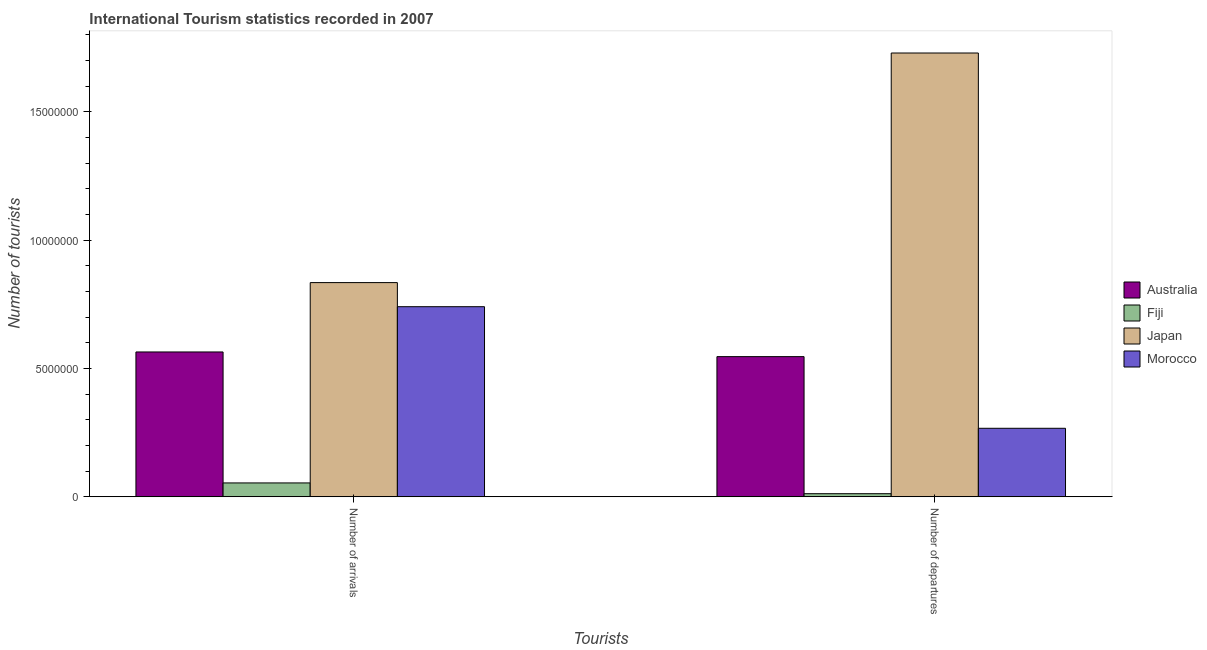How many different coloured bars are there?
Ensure brevity in your answer.  4. How many groups of bars are there?
Make the answer very short. 2. Are the number of bars on each tick of the X-axis equal?
Your response must be concise. Yes. What is the label of the 1st group of bars from the left?
Provide a short and direct response. Number of arrivals. What is the number of tourist departures in Australia?
Your answer should be compact. 5.46e+06. Across all countries, what is the maximum number of tourist arrivals?
Your response must be concise. 8.35e+06. Across all countries, what is the minimum number of tourist departures?
Provide a short and direct response. 1.20e+05. In which country was the number of tourist departures minimum?
Offer a terse response. Fiji. What is the total number of tourist departures in the graph?
Offer a terse response. 2.55e+07. What is the difference between the number of tourist arrivals in Australia and that in Japan?
Keep it short and to the point. -2.70e+06. What is the difference between the number of tourist departures in Japan and the number of tourist arrivals in Morocco?
Keep it short and to the point. 9.89e+06. What is the average number of tourist arrivals per country?
Offer a very short reply. 5.48e+06. What is the difference between the number of tourist departures and number of tourist arrivals in Australia?
Provide a succinct answer. -1.82e+05. In how many countries, is the number of tourist departures greater than 16000000 ?
Provide a succinct answer. 1. What is the ratio of the number of tourist arrivals in Morocco to that in Fiji?
Keep it short and to the point. 13.72. In how many countries, is the number of tourist departures greater than the average number of tourist departures taken over all countries?
Make the answer very short. 1. What does the 3rd bar from the left in Number of departures represents?
Provide a succinct answer. Japan. How many bars are there?
Offer a terse response. 8. How many countries are there in the graph?
Make the answer very short. 4. Are the values on the major ticks of Y-axis written in scientific E-notation?
Your answer should be very brief. No. Does the graph contain grids?
Provide a succinct answer. No. Where does the legend appear in the graph?
Ensure brevity in your answer.  Center right. How many legend labels are there?
Your answer should be very brief. 4. What is the title of the graph?
Offer a terse response. International Tourism statistics recorded in 2007. Does "Palau" appear as one of the legend labels in the graph?
Provide a succinct answer. No. What is the label or title of the X-axis?
Give a very brief answer. Tourists. What is the label or title of the Y-axis?
Provide a succinct answer. Number of tourists. What is the Number of tourists of Australia in Number of arrivals?
Your answer should be very brief. 5.64e+06. What is the Number of tourists of Fiji in Number of arrivals?
Offer a very short reply. 5.40e+05. What is the Number of tourists of Japan in Number of arrivals?
Provide a succinct answer. 8.35e+06. What is the Number of tourists of Morocco in Number of arrivals?
Your answer should be very brief. 7.41e+06. What is the Number of tourists of Australia in Number of departures?
Provide a succinct answer. 5.46e+06. What is the Number of tourists of Fiji in Number of departures?
Keep it short and to the point. 1.20e+05. What is the Number of tourists of Japan in Number of departures?
Your response must be concise. 1.73e+07. What is the Number of tourists in Morocco in Number of departures?
Provide a short and direct response. 2.67e+06. Across all Tourists, what is the maximum Number of tourists of Australia?
Give a very brief answer. 5.64e+06. Across all Tourists, what is the maximum Number of tourists in Fiji?
Your response must be concise. 5.40e+05. Across all Tourists, what is the maximum Number of tourists of Japan?
Give a very brief answer. 1.73e+07. Across all Tourists, what is the maximum Number of tourists in Morocco?
Offer a terse response. 7.41e+06. Across all Tourists, what is the minimum Number of tourists in Australia?
Give a very brief answer. 5.46e+06. Across all Tourists, what is the minimum Number of tourists in Fiji?
Offer a terse response. 1.20e+05. Across all Tourists, what is the minimum Number of tourists in Japan?
Give a very brief answer. 8.35e+06. Across all Tourists, what is the minimum Number of tourists of Morocco?
Keep it short and to the point. 2.67e+06. What is the total Number of tourists in Australia in the graph?
Your answer should be compact. 1.11e+07. What is the total Number of tourists of Fiji in the graph?
Ensure brevity in your answer.  6.60e+05. What is the total Number of tourists in Japan in the graph?
Offer a very short reply. 2.56e+07. What is the total Number of tourists in Morocco in the graph?
Make the answer very short. 1.01e+07. What is the difference between the Number of tourists of Australia in Number of arrivals and that in Number of departures?
Provide a short and direct response. 1.82e+05. What is the difference between the Number of tourists of Japan in Number of arrivals and that in Number of departures?
Your answer should be compact. -8.95e+06. What is the difference between the Number of tourists of Morocco in Number of arrivals and that in Number of departures?
Make the answer very short. 4.74e+06. What is the difference between the Number of tourists of Australia in Number of arrivals and the Number of tourists of Fiji in Number of departures?
Give a very brief answer. 5.52e+06. What is the difference between the Number of tourists in Australia in Number of arrivals and the Number of tourists in Japan in Number of departures?
Your answer should be very brief. -1.17e+07. What is the difference between the Number of tourists in Australia in Number of arrivals and the Number of tourists in Morocco in Number of departures?
Your response must be concise. 2.98e+06. What is the difference between the Number of tourists in Fiji in Number of arrivals and the Number of tourists in Japan in Number of departures?
Give a very brief answer. -1.68e+07. What is the difference between the Number of tourists of Fiji in Number of arrivals and the Number of tourists of Morocco in Number of departures?
Offer a very short reply. -2.13e+06. What is the difference between the Number of tourists in Japan in Number of arrivals and the Number of tourists in Morocco in Number of departures?
Your answer should be very brief. 5.68e+06. What is the average Number of tourists in Australia per Tourists?
Give a very brief answer. 5.55e+06. What is the average Number of tourists of Fiji per Tourists?
Offer a terse response. 3.30e+05. What is the average Number of tourists in Japan per Tourists?
Provide a succinct answer. 1.28e+07. What is the average Number of tourists in Morocco per Tourists?
Your response must be concise. 5.04e+06. What is the difference between the Number of tourists in Australia and Number of tourists in Fiji in Number of arrivals?
Offer a very short reply. 5.10e+06. What is the difference between the Number of tourists in Australia and Number of tourists in Japan in Number of arrivals?
Keep it short and to the point. -2.70e+06. What is the difference between the Number of tourists in Australia and Number of tourists in Morocco in Number of arrivals?
Offer a terse response. -1.76e+06. What is the difference between the Number of tourists in Fiji and Number of tourists in Japan in Number of arrivals?
Make the answer very short. -7.81e+06. What is the difference between the Number of tourists of Fiji and Number of tourists of Morocco in Number of arrivals?
Offer a terse response. -6.87e+06. What is the difference between the Number of tourists in Japan and Number of tourists in Morocco in Number of arrivals?
Provide a short and direct response. 9.39e+05. What is the difference between the Number of tourists in Australia and Number of tourists in Fiji in Number of departures?
Give a very brief answer. 5.34e+06. What is the difference between the Number of tourists in Australia and Number of tourists in Japan in Number of departures?
Your response must be concise. -1.18e+07. What is the difference between the Number of tourists in Australia and Number of tourists in Morocco in Number of departures?
Keep it short and to the point. 2.79e+06. What is the difference between the Number of tourists in Fiji and Number of tourists in Japan in Number of departures?
Offer a very short reply. -1.72e+07. What is the difference between the Number of tourists of Fiji and Number of tourists of Morocco in Number of departures?
Keep it short and to the point. -2.55e+06. What is the difference between the Number of tourists in Japan and Number of tourists in Morocco in Number of departures?
Keep it short and to the point. 1.46e+07. What is the ratio of the Number of tourists in Australia in Number of arrivals to that in Number of departures?
Your answer should be very brief. 1.03. What is the ratio of the Number of tourists of Japan in Number of arrivals to that in Number of departures?
Ensure brevity in your answer.  0.48. What is the ratio of the Number of tourists in Morocco in Number of arrivals to that in Number of departures?
Give a very brief answer. 2.78. What is the difference between the highest and the second highest Number of tourists in Australia?
Your answer should be very brief. 1.82e+05. What is the difference between the highest and the second highest Number of tourists in Japan?
Ensure brevity in your answer.  8.95e+06. What is the difference between the highest and the second highest Number of tourists of Morocco?
Offer a very short reply. 4.74e+06. What is the difference between the highest and the lowest Number of tourists in Australia?
Your answer should be very brief. 1.82e+05. What is the difference between the highest and the lowest Number of tourists in Japan?
Ensure brevity in your answer.  8.95e+06. What is the difference between the highest and the lowest Number of tourists of Morocco?
Give a very brief answer. 4.74e+06. 